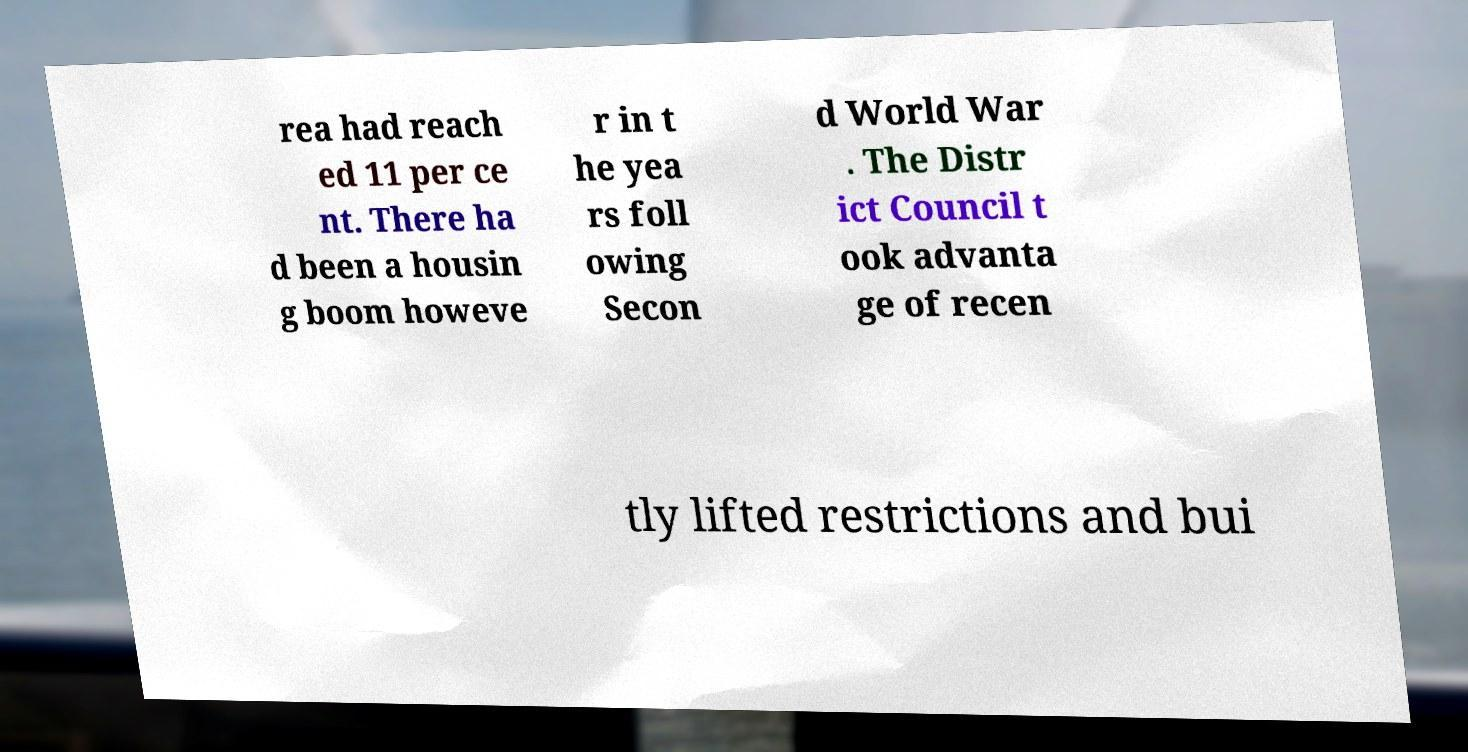Please identify and transcribe the text found in this image. rea had reach ed 11 per ce nt. There ha d been a housin g boom howeve r in t he yea rs foll owing Secon d World War . The Distr ict Council t ook advanta ge of recen tly lifted restrictions and bui 